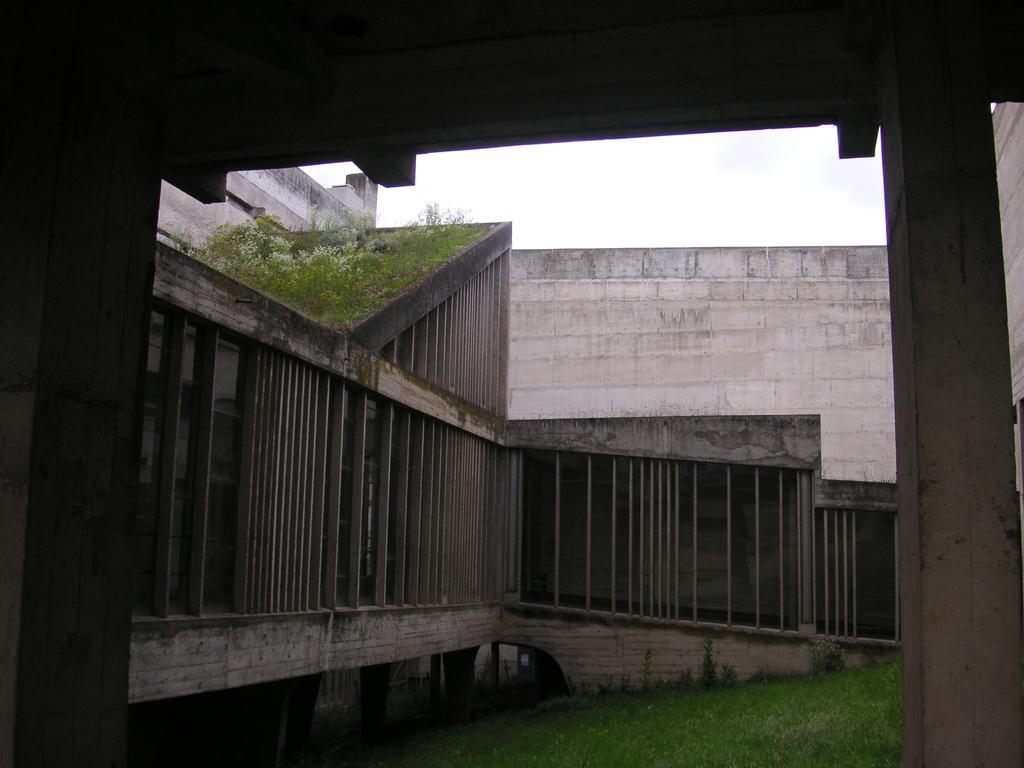Can you describe this image briefly? In this image, we can see a building and there are some plants. At the bottom, there is ground. 